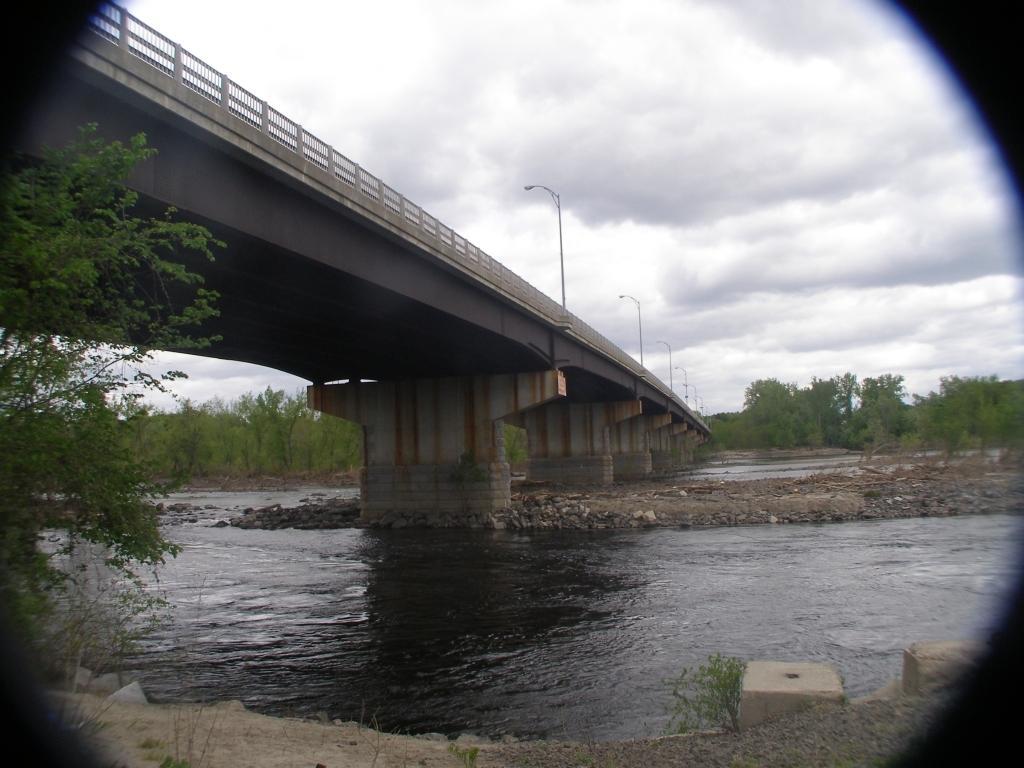Please provide a concise description of this image. In this image we can see a bridge. There is water. In the background of the image there are trees. At the top of the image there are clouds. There are street lights. 